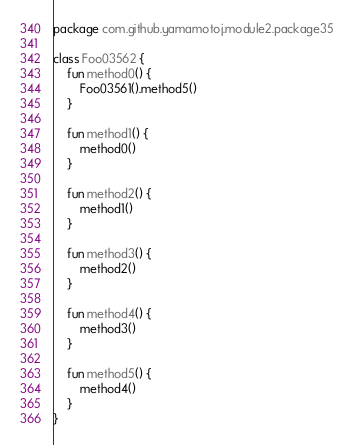<code> <loc_0><loc_0><loc_500><loc_500><_Kotlin_>package com.github.yamamotoj.module2.package35

class Foo03562 {
    fun method0() {
        Foo03561().method5()
    }

    fun method1() {
        method0()
    }

    fun method2() {
        method1()
    }

    fun method3() {
        method2()
    }

    fun method4() {
        method3()
    }

    fun method5() {
        method4()
    }
}
</code> 